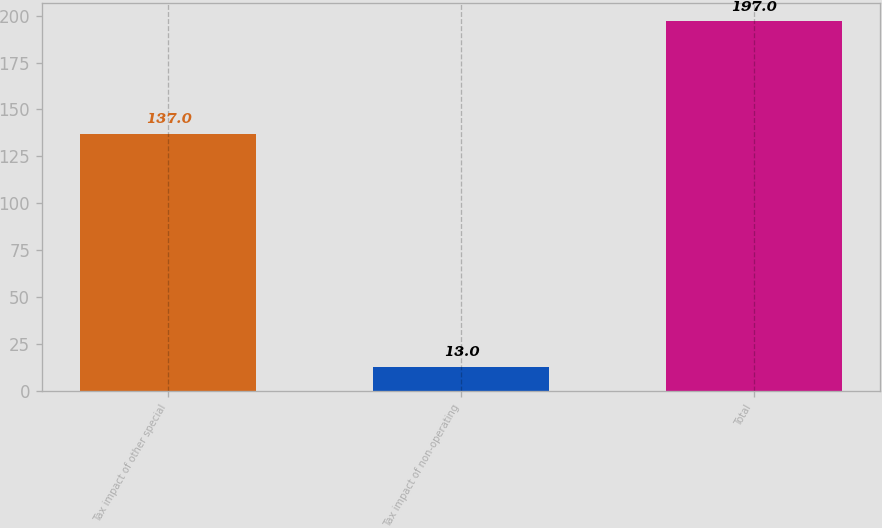Convert chart to OTSL. <chart><loc_0><loc_0><loc_500><loc_500><bar_chart><fcel>Tax impact of other special<fcel>Tax impact of non-operating<fcel>Total<nl><fcel>137<fcel>13<fcel>197<nl></chart> 